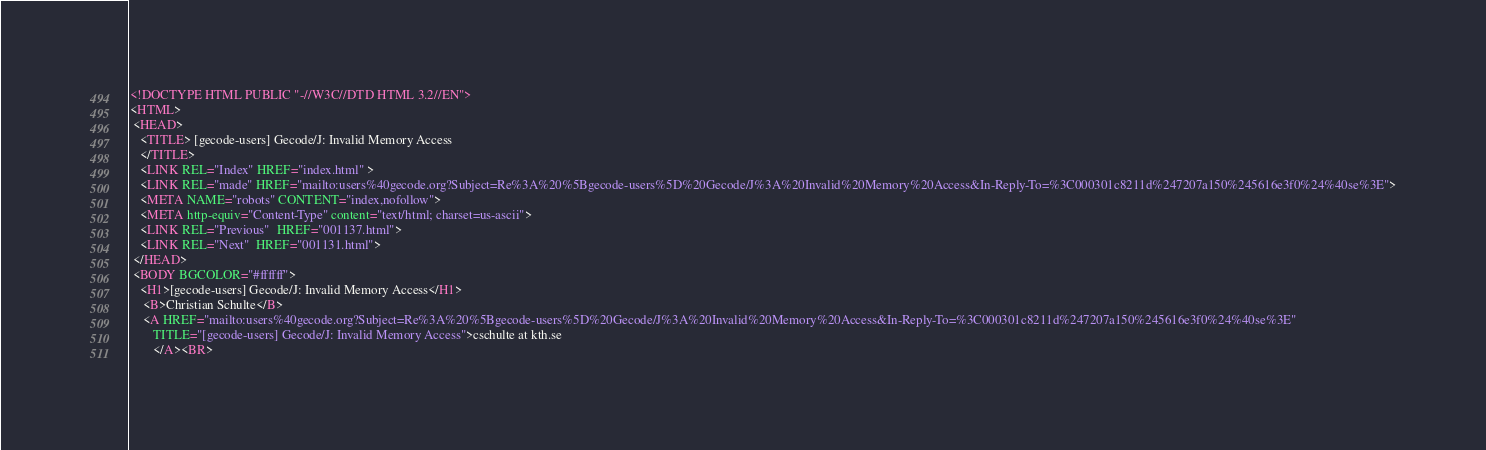<code> <loc_0><loc_0><loc_500><loc_500><_HTML_><!DOCTYPE HTML PUBLIC "-//W3C//DTD HTML 3.2//EN">
<HTML>
 <HEAD>
   <TITLE> [gecode-users] Gecode/J: Invalid Memory Access
   </TITLE>
   <LINK REL="Index" HREF="index.html" >
   <LINK REL="made" HREF="mailto:users%40gecode.org?Subject=Re%3A%20%5Bgecode-users%5D%20Gecode/J%3A%20Invalid%20Memory%20Access&In-Reply-To=%3C000301c8211d%247207a150%245616e3f0%24%40se%3E">
   <META NAME="robots" CONTENT="index,nofollow">
   <META http-equiv="Content-Type" content="text/html; charset=us-ascii">
   <LINK REL="Previous"  HREF="001137.html">
   <LINK REL="Next"  HREF="001131.html">
 </HEAD>
 <BODY BGCOLOR="#ffffff">
   <H1>[gecode-users] Gecode/J: Invalid Memory Access</H1>
    <B>Christian Schulte</B> 
    <A HREF="mailto:users%40gecode.org?Subject=Re%3A%20%5Bgecode-users%5D%20Gecode/J%3A%20Invalid%20Memory%20Access&In-Reply-To=%3C000301c8211d%247207a150%245616e3f0%24%40se%3E"
       TITLE="[gecode-users] Gecode/J: Invalid Memory Access">cschulte at kth.se
       </A><BR></code> 